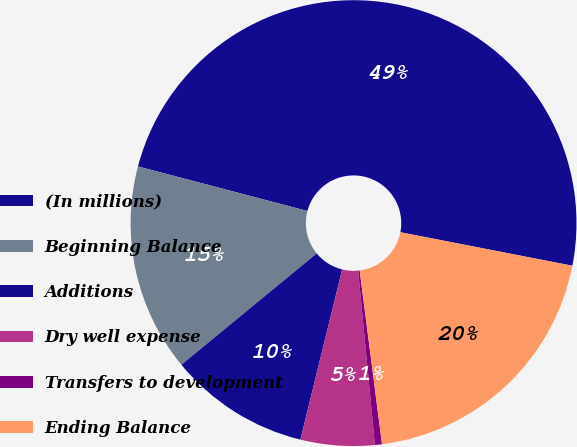Convert chart to OTSL. <chart><loc_0><loc_0><loc_500><loc_500><pie_chart><fcel>(In millions)<fcel>Beginning Balance<fcel>Additions<fcel>Dry well expense<fcel>Transfers to development<fcel>Ending Balance<nl><fcel>48.97%<fcel>15.05%<fcel>10.21%<fcel>5.36%<fcel>0.51%<fcel>19.9%<nl></chart> 